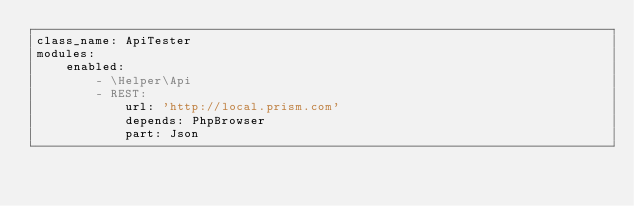<code> <loc_0><loc_0><loc_500><loc_500><_YAML_>class_name: ApiTester
modules:
    enabled:
        - \Helper\Api
        - REST:
            url: 'http://local.prism.com'
            depends: PhpBrowser
            part: Json
</code> 